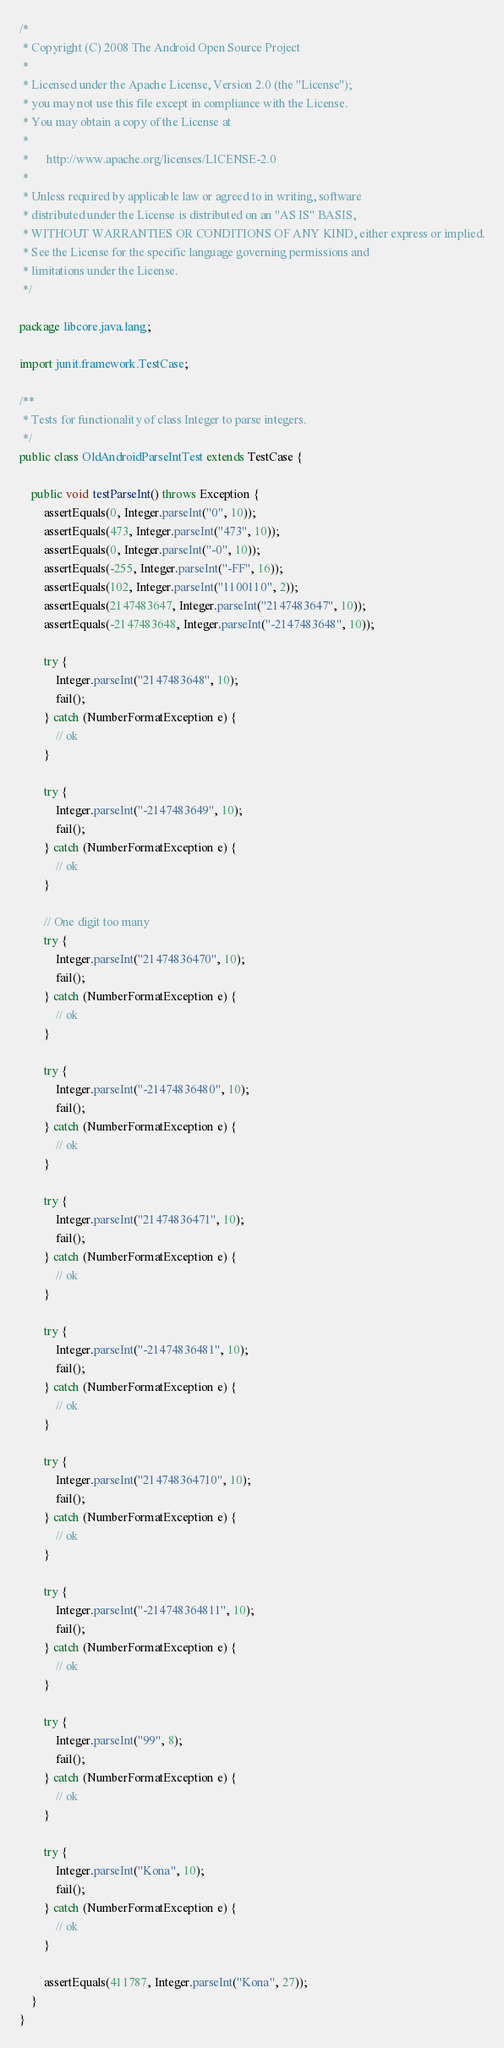<code> <loc_0><loc_0><loc_500><loc_500><_Java_>/*
 * Copyright (C) 2008 The Android Open Source Project
 *
 * Licensed under the Apache License, Version 2.0 (the "License");
 * you may not use this file except in compliance with the License.
 * You may obtain a copy of the License at
 *
 *      http://www.apache.org/licenses/LICENSE-2.0
 *
 * Unless required by applicable law or agreed to in writing, software
 * distributed under the License is distributed on an "AS IS" BASIS,
 * WITHOUT WARRANTIES OR CONDITIONS OF ANY KIND, either express or implied.
 * See the License for the specific language governing permissions and
 * limitations under the License.
 */

package libcore.java.lang;

import junit.framework.TestCase;

/**
 * Tests for functionality of class Integer to parse integers.
 */
public class OldAndroidParseIntTest extends TestCase {

    public void testParseInt() throws Exception {
        assertEquals(0, Integer.parseInt("0", 10));
        assertEquals(473, Integer.parseInt("473", 10));
        assertEquals(0, Integer.parseInt("-0", 10));
        assertEquals(-255, Integer.parseInt("-FF", 16));
        assertEquals(102, Integer.parseInt("1100110", 2));
        assertEquals(2147483647, Integer.parseInt("2147483647", 10));
        assertEquals(-2147483648, Integer.parseInt("-2147483648", 10));

        try {
            Integer.parseInt("2147483648", 10);
            fail();
        } catch (NumberFormatException e) {
            // ok
        }

        try {
            Integer.parseInt("-2147483649", 10);
            fail();
        } catch (NumberFormatException e) {
            // ok
        }

        // One digit too many
        try {
            Integer.parseInt("21474836470", 10);
            fail();
        } catch (NumberFormatException e) {
            // ok
        }

        try {
            Integer.parseInt("-21474836480", 10);
            fail();
        } catch (NumberFormatException e) {
            // ok
        }

        try {
            Integer.parseInt("21474836471", 10);
            fail();
        } catch (NumberFormatException e) {
            // ok
        }

        try {
            Integer.parseInt("-21474836481", 10);
            fail();
        } catch (NumberFormatException e) {
            // ok
        }

        try {
            Integer.parseInt("214748364710", 10);
            fail();
        } catch (NumberFormatException e) {
            // ok
        }

        try {
            Integer.parseInt("-214748364811", 10);
            fail();
        } catch (NumberFormatException e) {
            // ok
        }

        try {
            Integer.parseInt("99", 8);
            fail();
        } catch (NumberFormatException e) {
            // ok
        }

        try {
            Integer.parseInt("Kona", 10);
            fail();
        } catch (NumberFormatException e) {
            // ok
        }

        assertEquals(411787, Integer.parseInt("Kona", 27));
    }
}
</code> 